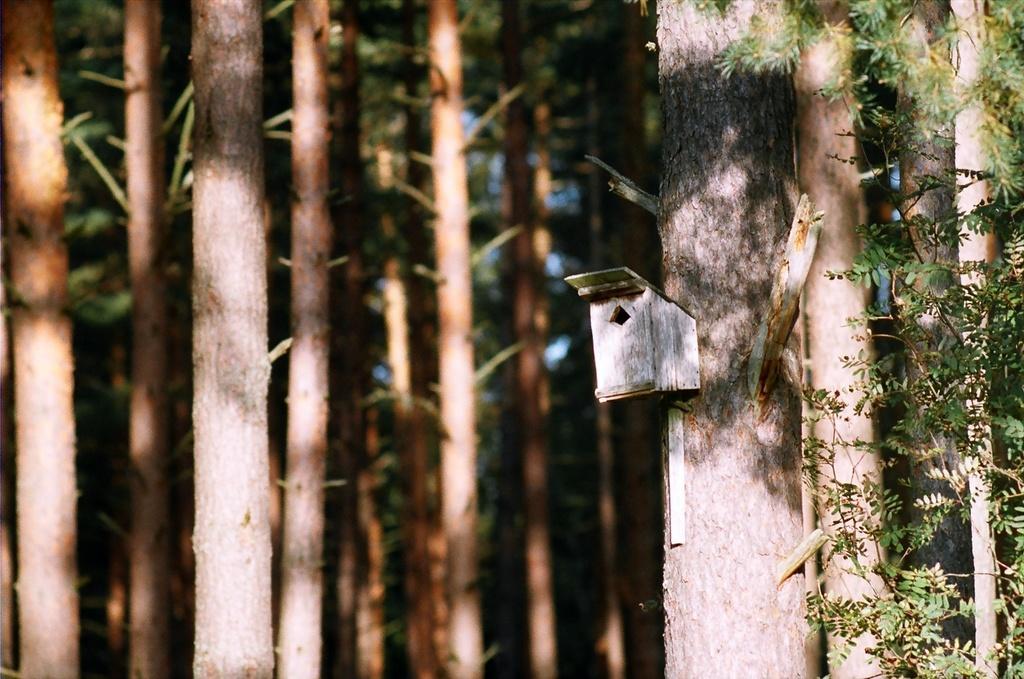Describe this image in one or two sentences. In this picture we can see a wooden object and in the background we can see trees. 